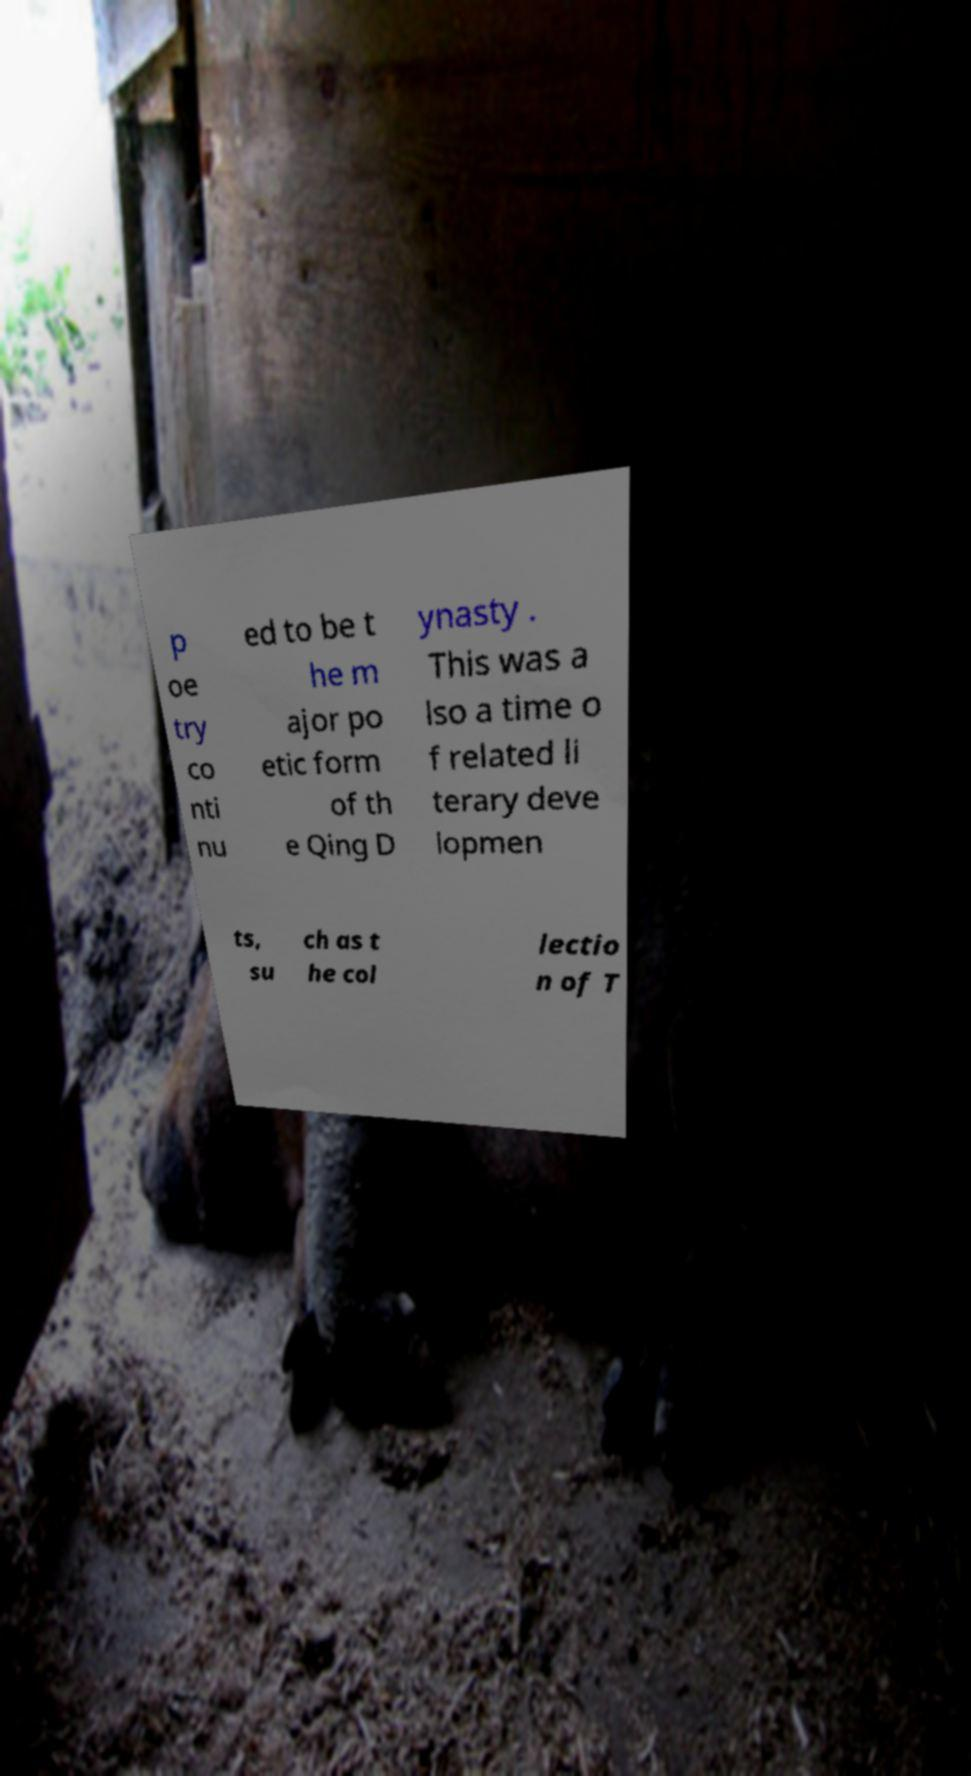Please identify and transcribe the text found in this image. p oe try co nti nu ed to be t he m ajor po etic form of th e Qing D ynasty . This was a lso a time o f related li terary deve lopmen ts, su ch as t he col lectio n of T 